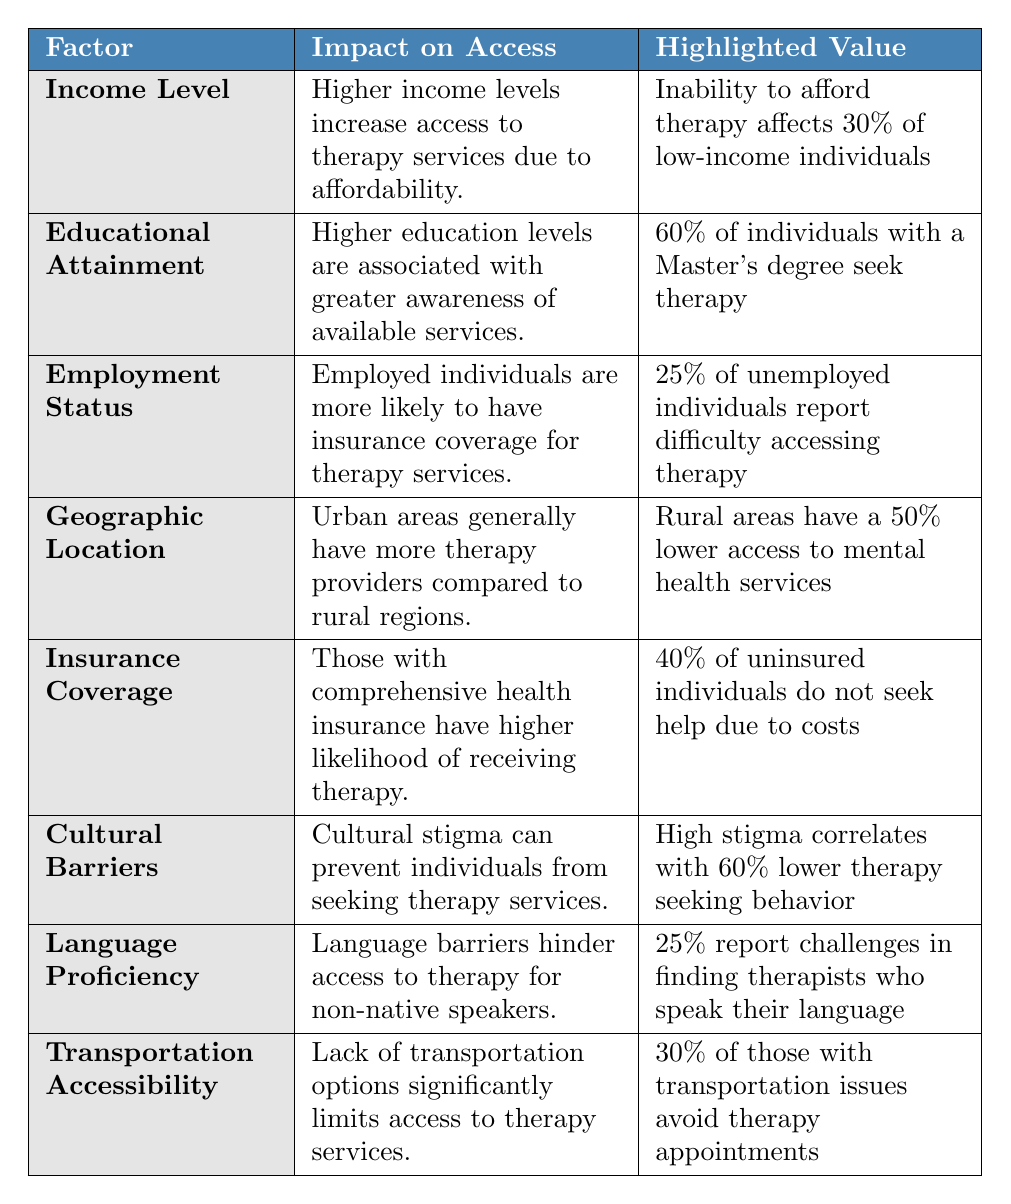What percentage of low-income individuals cannot afford therapy? The table specifically states that 30% of low-income individuals report difficulty affording therapy. Thus, the highlighted value directly provides the answer.
Answer: 30% What is the impact of educational attainment on seeking therapy services? The table notes that higher education levels correlate with greater awareness of therapy services and states that 60% of individuals with a Master's degree seek therapy.
Answer: Higher education increases awareness and therapy seeking What is the access level to therapy services for unemployed individuals? The highlighted value indicates that 25% of unemployed individuals report difficulty accessing therapy, suggesting a significant barrier due to their employment status.
Answer: 25% How do rural areas compare to urban areas in terms of therapy service access? The table indicates that rural areas have 50% lower access to mental health services compared to urban areas, which have more therapy providers (3:1 ratio).
Answer: Rural areas have 50% lower access How many uninsured individuals do not seek help due to costs? According to the table, 40% of uninsured individuals do not seek help because of cost issues, which answers the retrieval aspect of this question.
Answer: 40% Is cultural stigma a barrier to accessing therapy services? The data notes that 35% of minority communities report cultural stigma, and high stigma correlates with a 60% lower therapy-seeking behavior, indicating that stigma is indeed a barrier.
Answer: Yes How might language proficiency impact therapy access for non-native speakers? The table shows that 20% of therapy seekers need language support, and 25% of them face challenges finding therapists who speak their language, indicating a clear language barrier.
Answer: Language barriers hinder access What is the combined impact of transportation issues on therapy appointments? The highlighted value mentions that 30% of individuals with transportation issues avoid therapy appointments, suggesting a consistent transportation barrier affecting access.
Answer: 30% avoid therapy due to transportation If there are 100 unemployed individuals, how many might find it difficult to access therapy? With 25% of unemployed individuals reporting access issues, you calculate 25% of 100, which is 25 individuals.
Answer: 25 individuals Which factor affects therapy services access the most based on the table? Analyzing the highlighted values indicates that cultural stigma (60% lower therapy-seeking behavior) may exert the most profound impact, followed by cost apprehensions among the uninsured.
Answer: Cultural stigma 